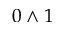Convert formula to latex. <formula><loc_0><loc_0><loc_500><loc_500>0 \wedge 1</formula> 